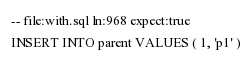<code> <loc_0><loc_0><loc_500><loc_500><_SQL_>-- file:with.sql ln:968 expect:true
INSERT INTO parent VALUES ( 1, 'p1' )
</code> 